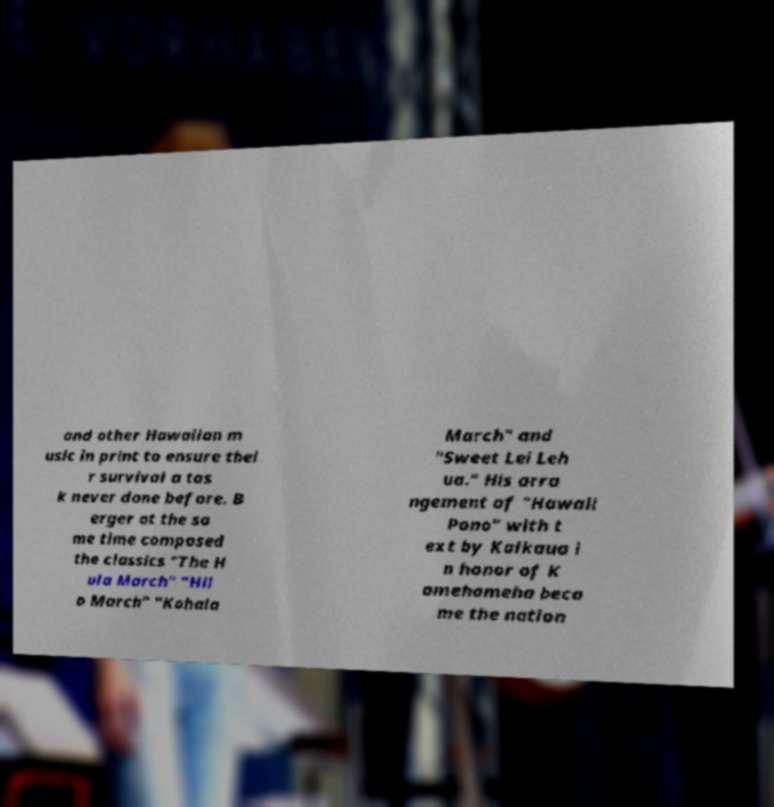Could you assist in decoding the text presented in this image and type it out clearly? and other Hawaiian m usic in print to ensure thei r survival a tas k never done before. B erger at the sa me time composed the classics "The H ula March" "Hil o March" "Kohala March" and "Sweet Lei Leh ua." His arra ngement of "Hawaii Pono" with t ext by Kalkaua i n honor of K amehameha beca me the nation 